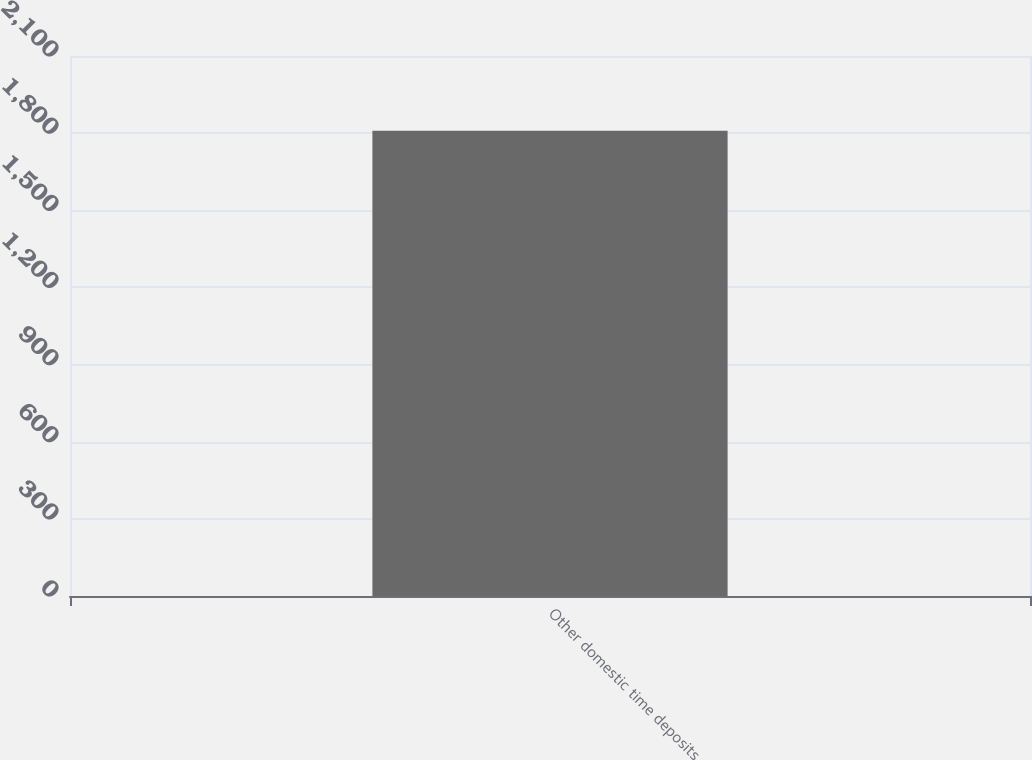Convert chart to OTSL. <chart><loc_0><loc_0><loc_500><loc_500><bar_chart><fcel>Other domestic time deposits<nl><fcel>1809<nl></chart> 